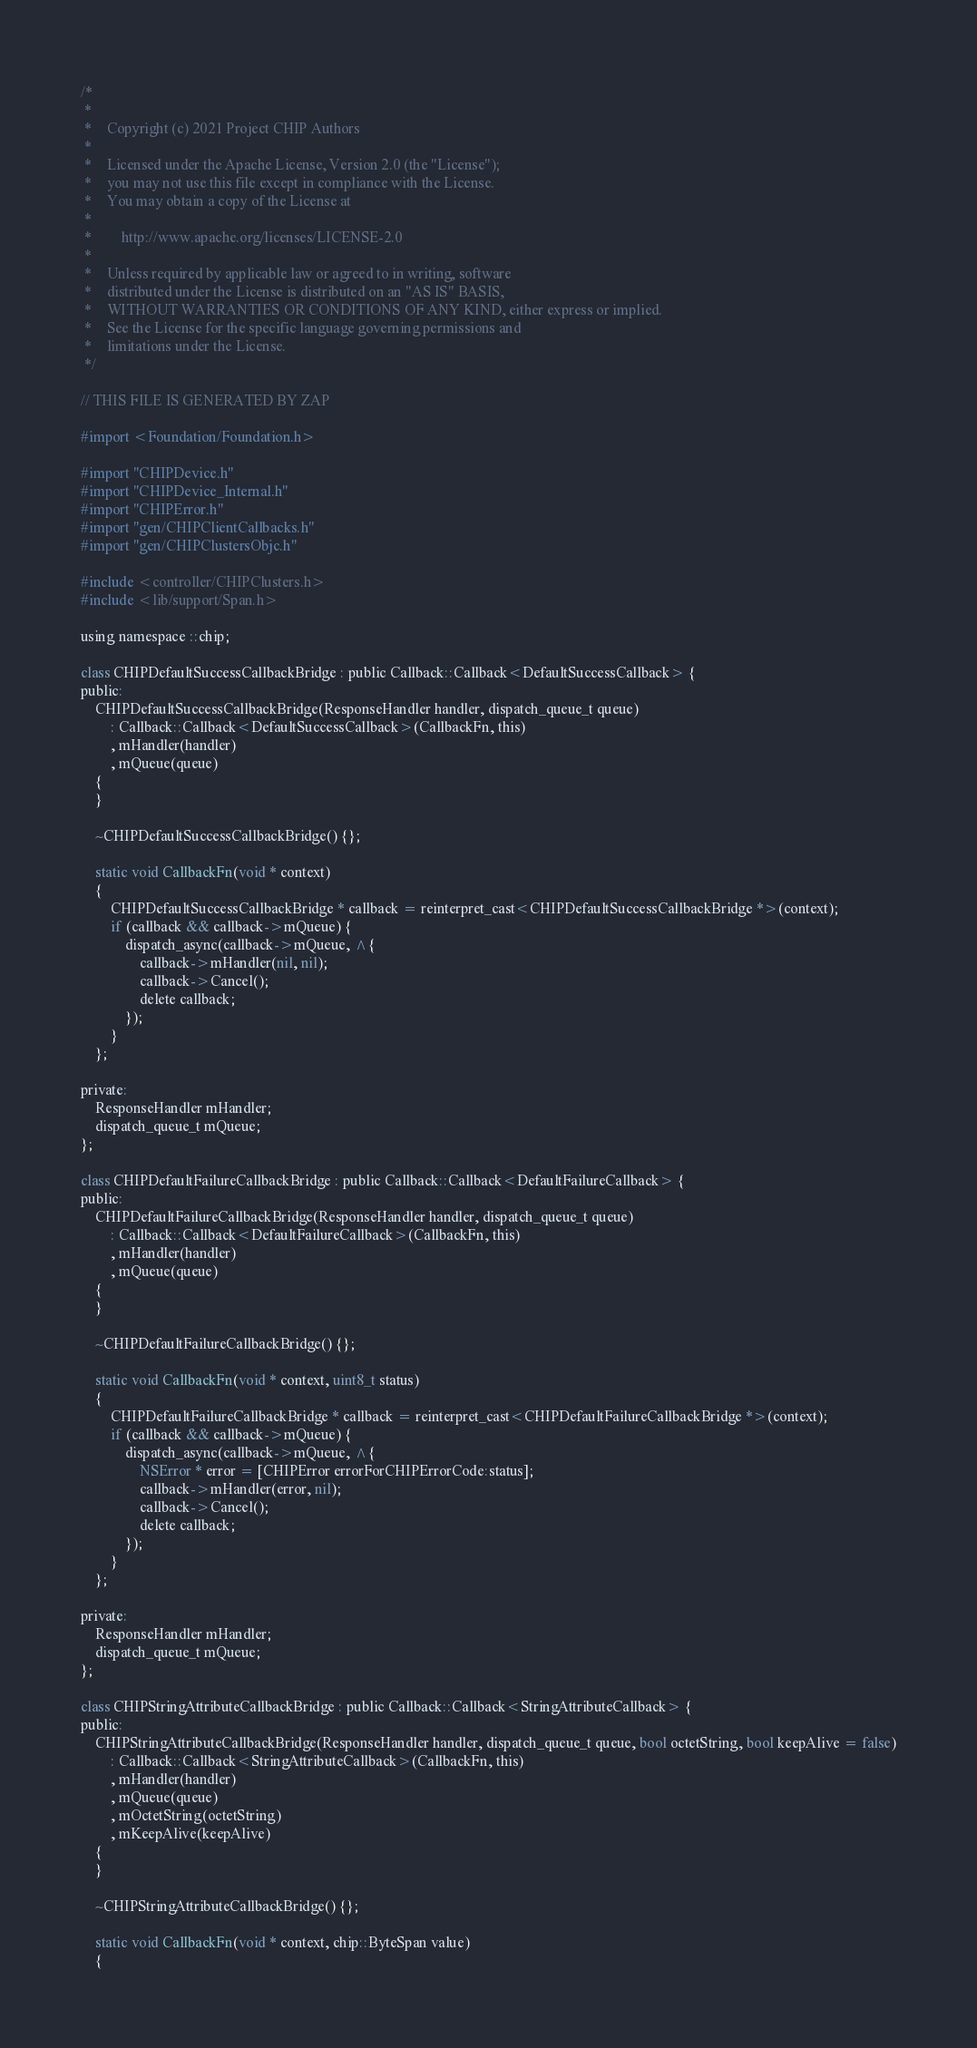<code> <loc_0><loc_0><loc_500><loc_500><_ObjectiveC_>/*
 *
 *    Copyright (c) 2021 Project CHIP Authors
 *
 *    Licensed under the Apache License, Version 2.0 (the "License");
 *    you may not use this file except in compliance with the License.
 *    You may obtain a copy of the License at
 *
 *        http://www.apache.org/licenses/LICENSE-2.0
 *
 *    Unless required by applicable law or agreed to in writing, software
 *    distributed under the License is distributed on an "AS IS" BASIS,
 *    WITHOUT WARRANTIES OR CONDITIONS OF ANY KIND, either express or implied.
 *    See the License for the specific language governing permissions and
 *    limitations under the License.
 */

// THIS FILE IS GENERATED BY ZAP

#import <Foundation/Foundation.h>

#import "CHIPDevice.h"
#import "CHIPDevice_Internal.h"
#import "CHIPError.h"
#import "gen/CHIPClientCallbacks.h"
#import "gen/CHIPClustersObjc.h"

#include <controller/CHIPClusters.h>
#include <lib/support/Span.h>

using namespace ::chip;

class CHIPDefaultSuccessCallbackBridge : public Callback::Callback<DefaultSuccessCallback> {
public:
    CHIPDefaultSuccessCallbackBridge(ResponseHandler handler, dispatch_queue_t queue)
        : Callback::Callback<DefaultSuccessCallback>(CallbackFn, this)
        , mHandler(handler)
        , mQueue(queue)
    {
    }

    ~CHIPDefaultSuccessCallbackBridge() {};

    static void CallbackFn(void * context)
    {
        CHIPDefaultSuccessCallbackBridge * callback = reinterpret_cast<CHIPDefaultSuccessCallbackBridge *>(context);
        if (callback && callback->mQueue) {
            dispatch_async(callback->mQueue, ^{
                callback->mHandler(nil, nil);
                callback->Cancel();
                delete callback;
            });
        }
    };

private:
    ResponseHandler mHandler;
    dispatch_queue_t mQueue;
};

class CHIPDefaultFailureCallbackBridge : public Callback::Callback<DefaultFailureCallback> {
public:
    CHIPDefaultFailureCallbackBridge(ResponseHandler handler, dispatch_queue_t queue)
        : Callback::Callback<DefaultFailureCallback>(CallbackFn, this)
        , mHandler(handler)
        , mQueue(queue)
    {
    }

    ~CHIPDefaultFailureCallbackBridge() {};

    static void CallbackFn(void * context, uint8_t status)
    {
        CHIPDefaultFailureCallbackBridge * callback = reinterpret_cast<CHIPDefaultFailureCallbackBridge *>(context);
        if (callback && callback->mQueue) {
            dispatch_async(callback->mQueue, ^{
                NSError * error = [CHIPError errorForCHIPErrorCode:status];
                callback->mHandler(error, nil);
                callback->Cancel();
                delete callback;
            });
        }
    };

private:
    ResponseHandler mHandler;
    dispatch_queue_t mQueue;
};

class CHIPStringAttributeCallbackBridge : public Callback::Callback<StringAttributeCallback> {
public:
    CHIPStringAttributeCallbackBridge(ResponseHandler handler, dispatch_queue_t queue, bool octetString, bool keepAlive = false)
        : Callback::Callback<StringAttributeCallback>(CallbackFn, this)
        , mHandler(handler)
        , mQueue(queue)
        , mOctetString(octetString)
        , mKeepAlive(keepAlive)
    {
    }

    ~CHIPStringAttributeCallbackBridge() {};

    static void CallbackFn(void * context, chip::ByteSpan value)
    {</code> 